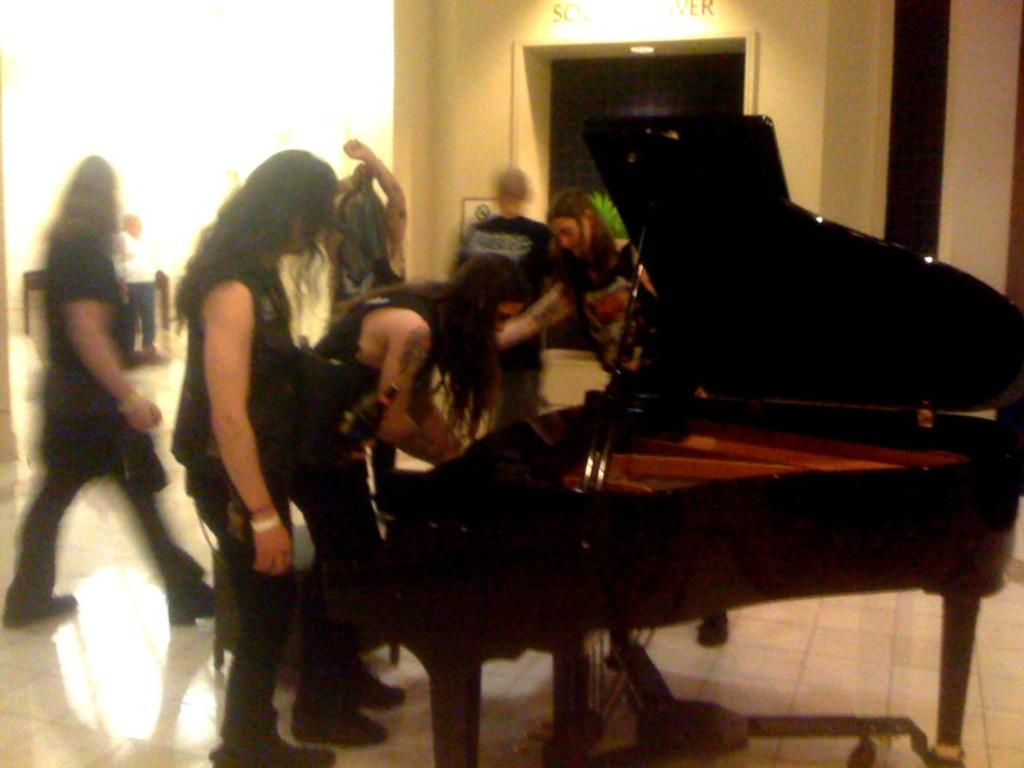What are the people in the image doing? The people in the image are on the floor. What object can be seen in the image besides the people? There is a keyboard in the image. What can be seen in the background of the image? There is a wall visible in the background of the image. What type of amusement can be seen in the image? There is no amusement present in the image; it features people on the floor and a keyboard. Can you tell me how many quills are being used by the people in the image? There are no quills present in the image. 